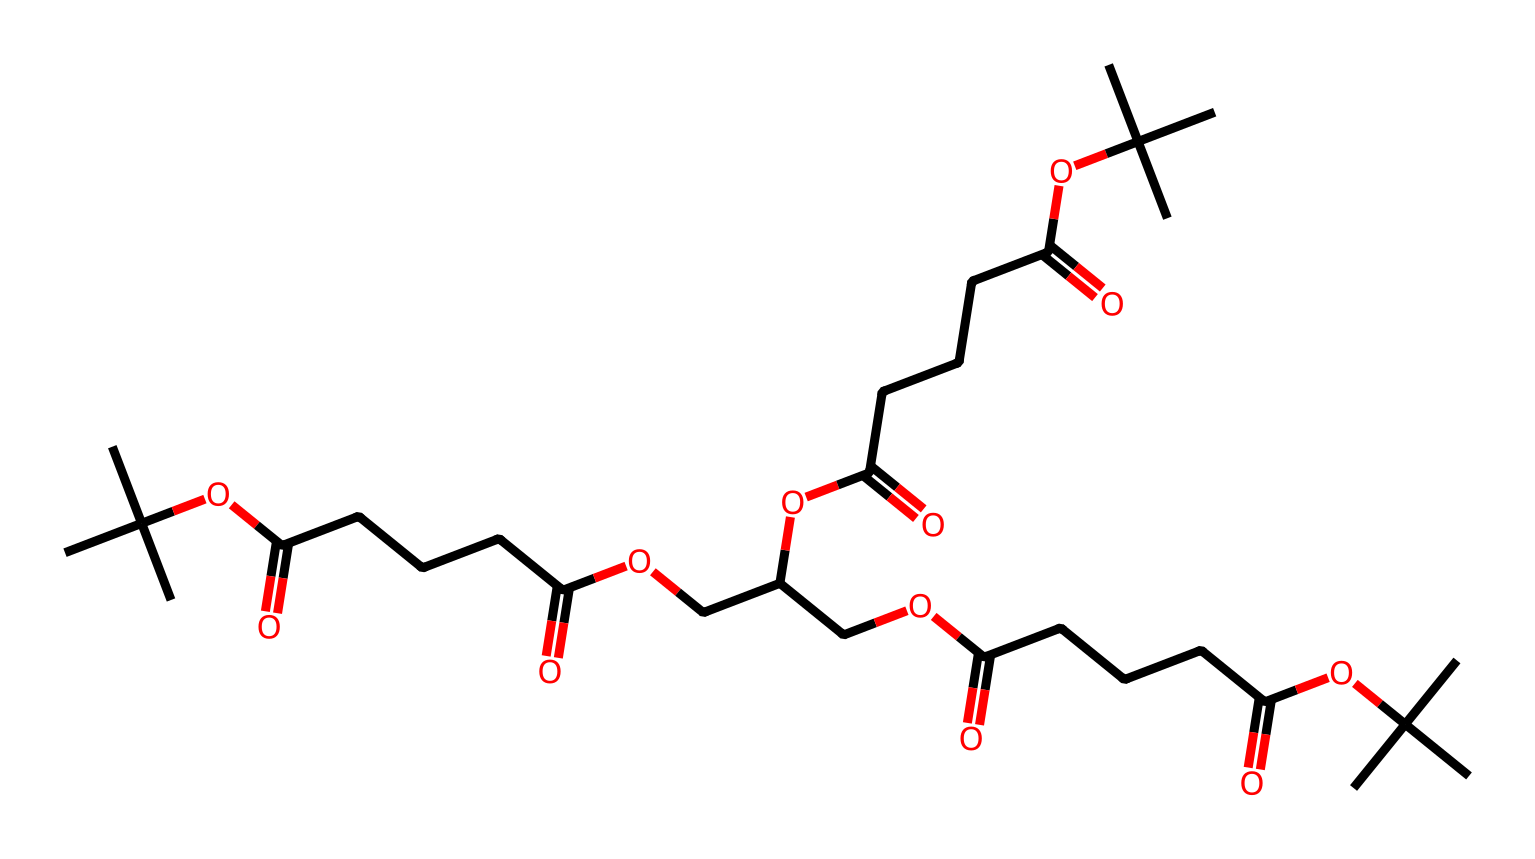What is the total number of carbon atoms in the structure? By analyzing the SMILES representation, I counted each carbon atom symbol 'C'. Careful consideration reveals there are 30 carbon atoms present in the chain complex.
Answer: 30 How many ester functional groups are present? Examining the structure, the ester groups are indicated by occurrences of 'OC(=O)' in the SMILES pattern. Counting these occurrences reveals a total of 4 ester groups in the compound.
Answer: 4 What type of polymer is represented by this chemical? The presence of multiple ester linkages and long hydrocarbon chains indicates this chemical is a poly(ester), commonly used in drug delivery systems for its biodegradable properties.
Answer: poly(ester) What is the approximate molecular weight of this compound? To find the molecular weight, we need to sum the atomic weights based on the count of each atom in the SMILES representation. Considering average atomic weights, the total comes to roughly 514.5 g/mol.
Answer: 514.5 g/mol How many carboxylic acid groups are there in this structure? The structure contains 'CCCC(=O)O', which represents carboxylic acid groups. There are 3 distinct instances of this functional group in the complex, confirming their presence.
Answer: 3 What is the degree of branching in the polymer? The structure shows branching points from the 'C(C)(C)' sections. Each branch leads to a significant number of carbon atoms, indicating a highly branched structure. The degree of branching is considered extensive due to the repeated branched formations.
Answer: extensive 